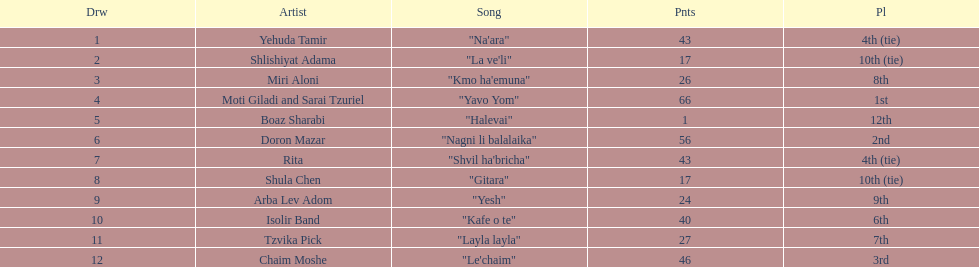Compare draws, which had the least amount of points? Boaz Sharabi. 